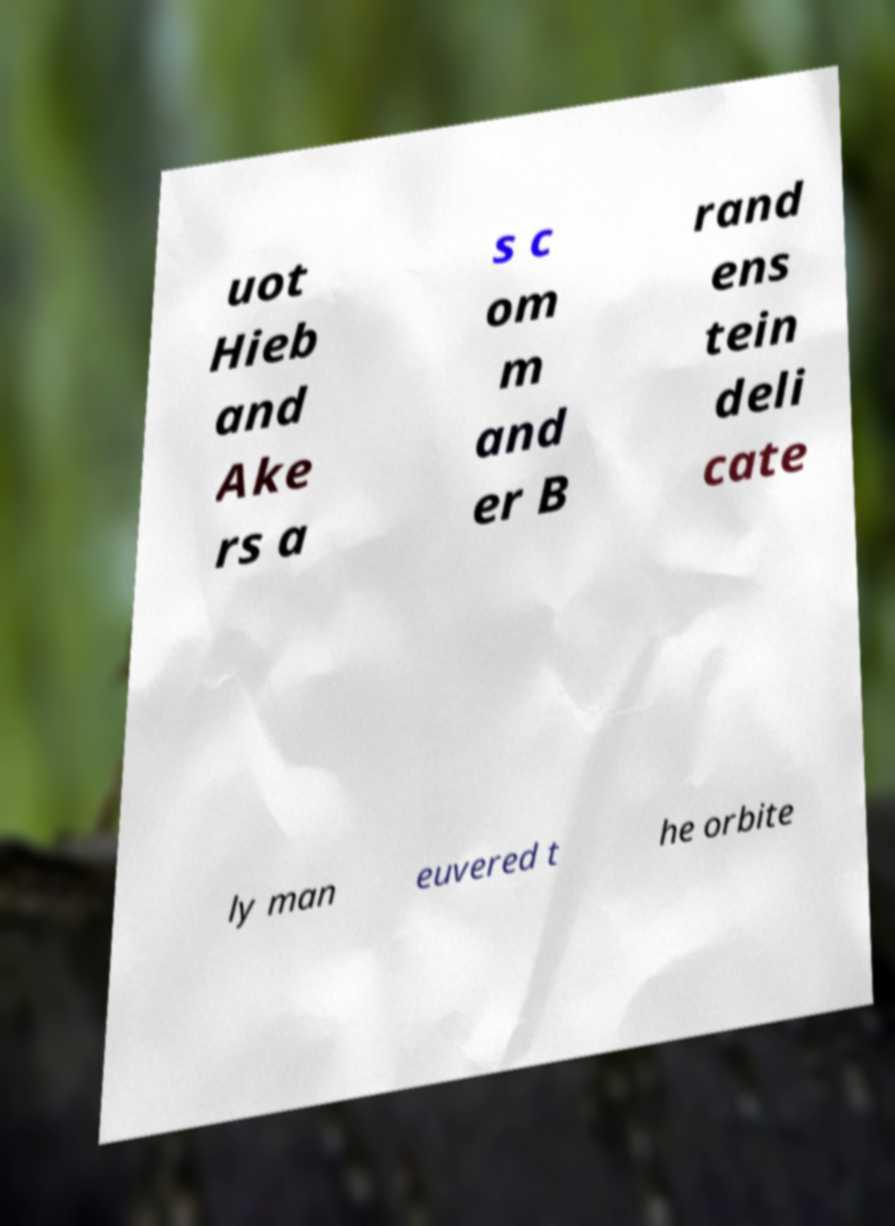Can you accurately transcribe the text from the provided image for me? uot Hieb and Ake rs a s c om m and er B rand ens tein deli cate ly man euvered t he orbite 